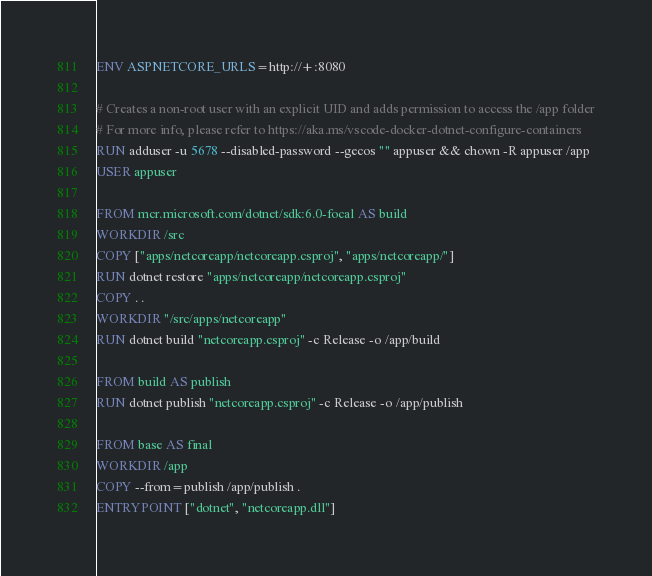<code> <loc_0><loc_0><loc_500><loc_500><_Dockerfile_>
ENV ASPNETCORE_URLS=http://+:8080

# Creates a non-root user with an explicit UID and adds permission to access the /app folder
# For more info, please refer to https://aka.ms/vscode-docker-dotnet-configure-containers
RUN adduser -u 5678 --disabled-password --gecos "" appuser && chown -R appuser /app
USER appuser

FROM mcr.microsoft.com/dotnet/sdk:6.0-focal AS build
WORKDIR /src
COPY ["apps/netcoreapp/netcoreapp.csproj", "apps/netcoreapp/"]
RUN dotnet restore "apps/netcoreapp/netcoreapp.csproj"
COPY . .
WORKDIR "/src/apps/netcoreapp"
RUN dotnet build "netcoreapp.csproj" -c Release -o /app/build

FROM build AS publish
RUN dotnet publish "netcoreapp.csproj" -c Release -o /app/publish

FROM base AS final
WORKDIR /app
COPY --from=publish /app/publish .
ENTRYPOINT ["dotnet", "netcoreapp.dll"]
</code> 